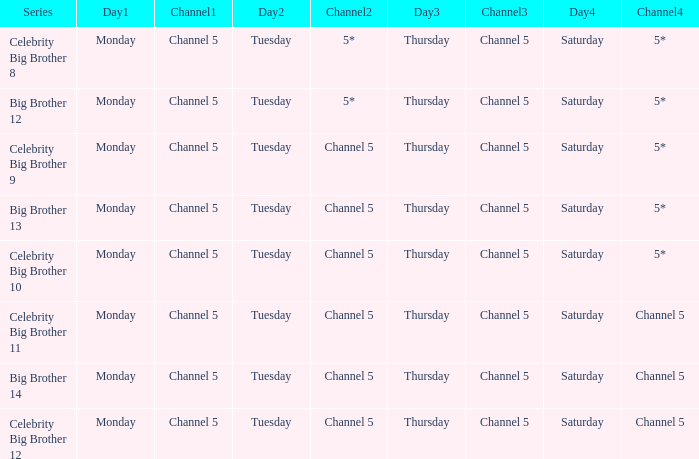On which thursday is big brother 13 scheduled to air? Channel 5. 